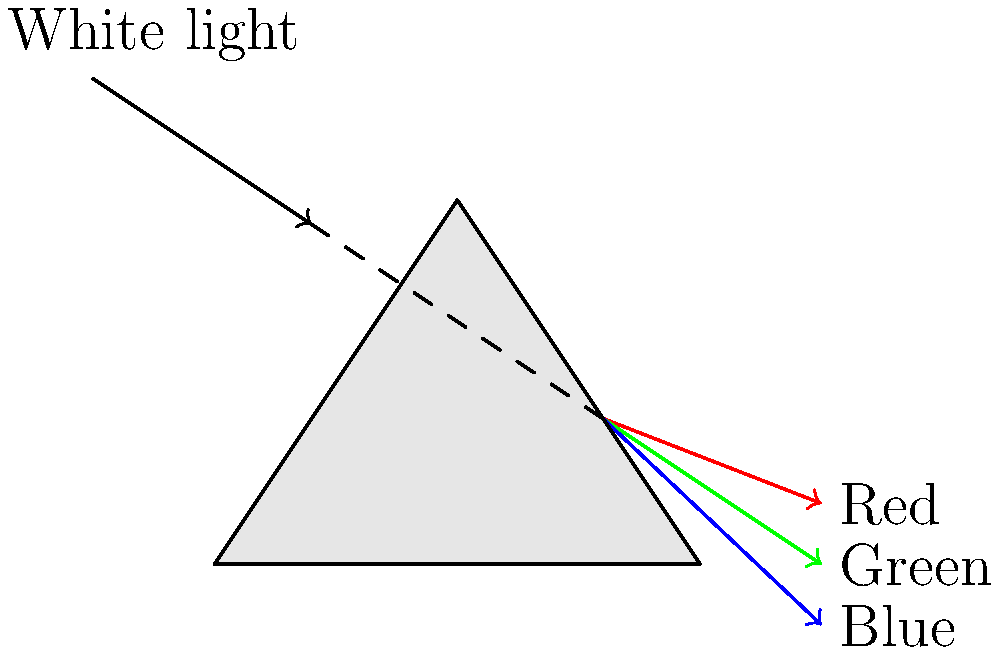As an artist teaching color theory in your online course, you want to explain how a prism separates white light into its component colors. If you shine white light through a glass prism, which color will be refracted the least (i.e., have the smallest angle of refraction)? To answer this question, we need to understand the principles of light refraction and dispersion:

1. When light enters a prism, it bends (refracts) due to the change in medium.

2. The amount of bending depends on the wavelength of light. This phenomenon is called dispersion.

3. The refractive index of a material varies with the wavelength of light. Generally, for visible light in glass:
   $n_{red} < n_{green} < n_{blue}$

4. According to Snell's law: $n_1 \sin \theta_1 = n_2 \sin \theta_2$, where $n_1$ and $n_2$ are the refractive indices of the two media, and $\theta_1$ and $\theta_2$ are the angles of incidence and refraction, respectively.

5. For a given angle of incidence, a higher refractive index results in a smaller angle of refraction.

6. Therefore, blue light (shortest wavelength) will bend the most, while red light (longest wavelength) will bend the least.

7. This creates the familiar rainbow effect, with red at the top and blue at the bottom of the spectrum.

In the context of art supplies, understanding this principle is crucial for artists working with light, color, and optical effects in their artwork.
Answer: Red 